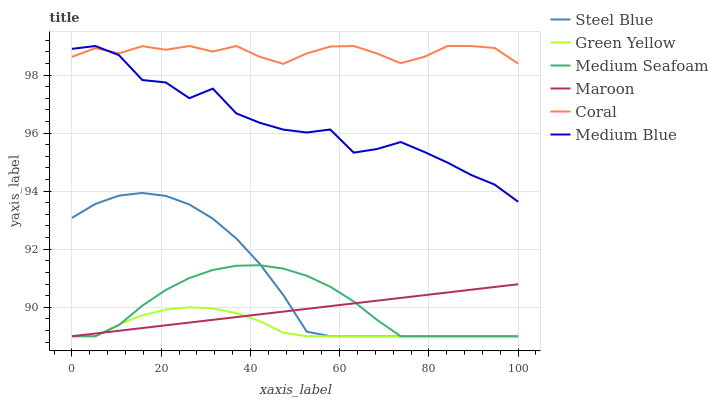Does Green Yellow have the minimum area under the curve?
Answer yes or no. Yes. Does Coral have the maximum area under the curve?
Answer yes or no. Yes. Does Medium Blue have the minimum area under the curve?
Answer yes or no. No. Does Medium Blue have the maximum area under the curve?
Answer yes or no. No. Is Maroon the smoothest?
Answer yes or no. Yes. Is Medium Blue the roughest?
Answer yes or no. Yes. Is Steel Blue the smoothest?
Answer yes or no. No. Is Steel Blue the roughest?
Answer yes or no. No. Does Steel Blue have the lowest value?
Answer yes or no. Yes. Does Medium Blue have the lowest value?
Answer yes or no. No. Does Medium Blue have the highest value?
Answer yes or no. Yes. Does Steel Blue have the highest value?
Answer yes or no. No. Is Green Yellow less than Coral?
Answer yes or no. Yes. Is Coral greater than Green Yellow?
Answer yes or no. Yes. Does Steel Blue intersect Maroon?
Answer yes or no. Yes. Is Steel Blue less than Maroon?
Answer yes or no. No. Is Steel Blue greater than Maroon?
Answer yes or no. No. Does Green Yellow intersect Coral?
Answer yes or no. No. 